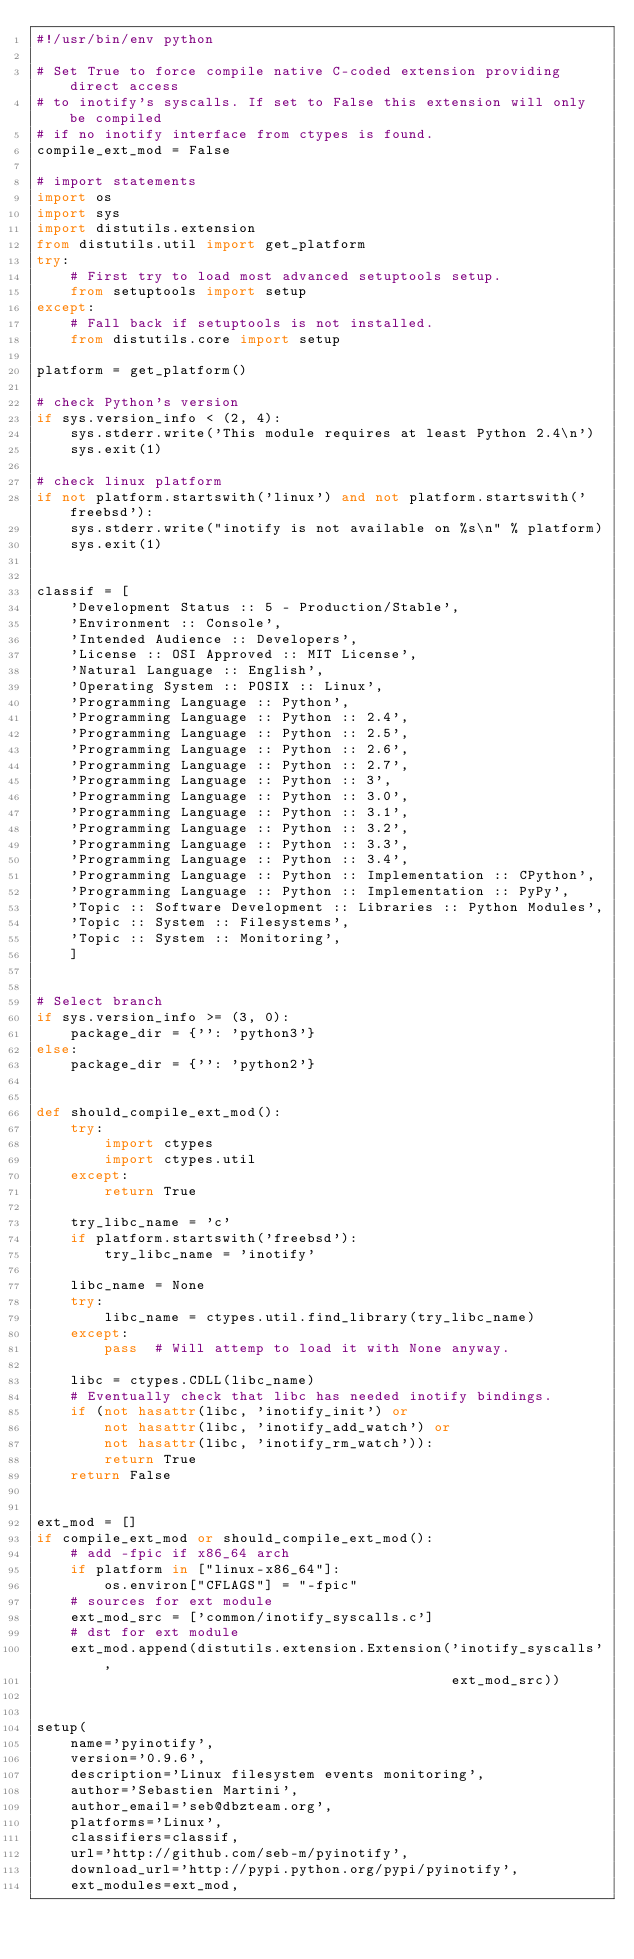Convert code to text. <code><loc_0><loc_0><loc_500><loc_500><_Python_>#!/usr/bin/env python

# Set True to force compile native C-coded extension providing direct access
# to inotify's syscalls. If set to False this extension will only be compiled
# if no inotify interface from ctypes is found.
compile_ext_mod = False

# import statements
import os
import sys
import distutils.extension
from distutils.util import get_platform
try:
    # First try to load most advanced setuptools setup.
    from setuptools import setup
except:
    # Fall back if setuptools is not installed.
    from distutils.core import setup

platform = get_platform()

# check Python's version
if sys.version_info < (2, 4):
    sys.stderr.write('This module requires at least Python 2.4\n')
    sys.exit(1)

# check linux platform
if not platform.startswith('linux') and not platform.startswith('freebsd'):
    sys.stderr.write("inotify is not available on %s\n" % platform)
    sys.exit(1)


classif = [
    'Development Status :: 5 - Production/Stable',
    'Environment :: Console',
    'Intended Audience :: Developers',
    'License :: OSI Approved :: MIT License',
    'Natural Language :: English',
    'Operating System :: POSIX :: Linux',
    'Programming Language :: Python',
    'Programming Language :: Python :: 2.4',
    'Programming Language :: Python :: 2.5',
    'Programming Language :: Python :: 2.6',
    'Programming Language :: Python :: 2.7',
    'Programming Language :: Python :: 3',
    'Programming Language :: Python :: 3.0',
    'Programming Language :: Python :: 3.1',
    'Programming Language :: Python :: 3.2',
    'Programming Language :: Python :: 3.3',
    'Programming Language :: Python :: 3.4',
    'Programming Language :: Python :: Implementation :: CPython',
    'Programming Language :: Python :: Implementation :: PyPy',
    'Topic :: Software Development :: Libraries :: Python Modules',
    'Topic :: System :: Filesystems',
    'Topic :: System :: Monitoring',
    ]


# Select branch
if sys.version_info >= (3, 0):
    package_dir = {'': 'python3'}
else:
    package_dir = {'': 'python2'}


def should_compile_ext_mod():
    try:
        import ctypes
        import ctypes.util
    except:
        return True

    try_libc_name = 'c'
    if platform.startswith('freebsd'):
        try_libc_name = 'inotify'

    libc_name = None
    try:
        libc_name = ctypes.util.find_library(try_libc_name)
    except:
        pass  # Will attemp to load it with None anyway.

    libc = ctypes.CDLL(libc_name)
    # Eventually check that libc has needed inotify bindings.
    if (not hasattr(libc, 'inotify_init') or
        not hasattr(libc, 'inotify_add_watch') or
        not hasattr(libc, 'inotify_rm_watch')):
        return True
    return False


ext_mod = []
if compile_ext_mod or should_compile_ext_mod():
    # add -fpic if x86_64 arch
    if platform in ["linux-x86_64"]:
        os.environ["CFLAGS"] = "-fpic"
    # sources for ext module
    ext_mod_src = ['common/inotify_syscalls.c']
    # dst for ext module
    ext_mod.append(distutils.extension.Extension('inotify_syscalls',
                                                 ext_mod_src))


setup(
    name='pyinotify',
    version='0.9.6',
    description='Linux filesystem events monitoring',
    author='Sebastien Martini',
    author_email='seb@dbzteam.org',
    platforms='Linux',
    classifiers=classif,
    url='http://github.com/seb-m/pyinotify',
    download_url='http://pypi.python.org/pypi/pyinotify',
    ext_modules=ext_mod,</code> 